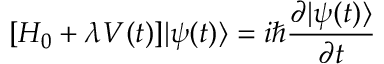<formula> <loc_0><loc_0><loc_500><loc_500>[ H _ { 0 } + \lambda V ( t ) ] | \psi ( t ) \rangle = i \hbar { \frac { \partial | \psi ( t ) \rangle } { \partial t } }</formula> 